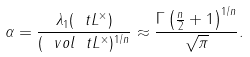<formula> <loc_0><loc_0><loc_500><loc_500>\alpha = \frac { \lambda _ { 1 } ( \ t L ^ { \times } ) } { ( \ v o l \ t L ^ { \times } ) ^ { 1 / n } } \approx \frac { \Gamma \left ( \frac { n } { 2 } + 1 \right ) ^ { 1 / n } } { \sqrt { \pi } } .</formula> 